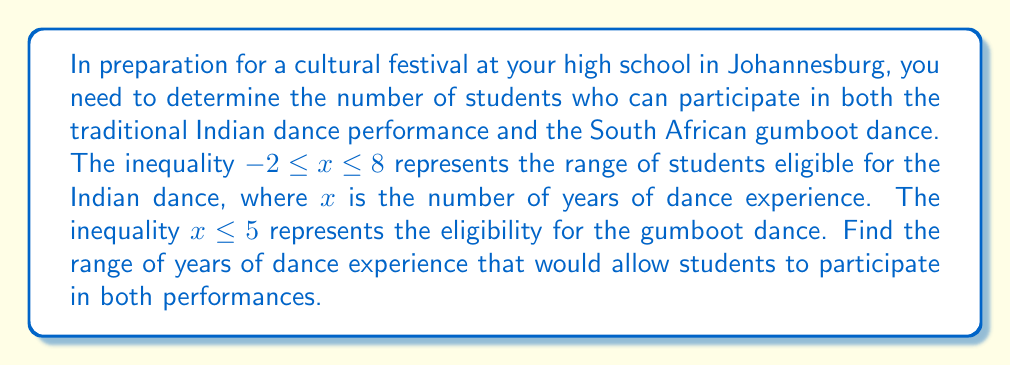Give your solution to this math problem. To solve this problem, we need to find the intersection of the two inequalities:

1) For the Indian dance: $-2 \leq x \leq 8$
2) For the gumboot dance: $x \leq 5$

Let's break this down step-by-step:

1) First, let's visualize these inequalities on a number line:

   [asy]
   import geometry;

   size(300,50);
   
   real[] ticks={-2,0,2,4,5,6,8};
   xaxis("",min=-3,max=9,Ticks(ticks));

   draw((-2,0.5)--(8,0.5),blue,Arrow);
   draw((-3,0.25)--(5,0.25),red,Arrow);

   label("Indian dance",(3,0.5),N,blue);
   label("Gumboot dance",(1,0.25),S,red);
   [/asy]

2) The blue line represents the Indian dance inequality, and the red line represents the gumboot dance inequality.

3) To participate in both, students must satisfy both inequalities simultaneously.

4) From the number line, we can see that the intersection starts at $-2$ (the lower bound of the Indian dance inequality) and ends at $5$ (the upper bound of the gumboot dance inequality).

5) Therefore, the intersection can be written as:

   $$-2 \leq x \leq 5$$

This means that students with dance experience ranging from 2 years or less (including no experience) up to 5 years can participate in both performances.
Answer: The range of years of dance experience for students to participate in both performances is $-2 \leq x \leq 5$. 